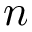<formula> <loc_0><loc_0><loc_500><loc_500>n</formula> 